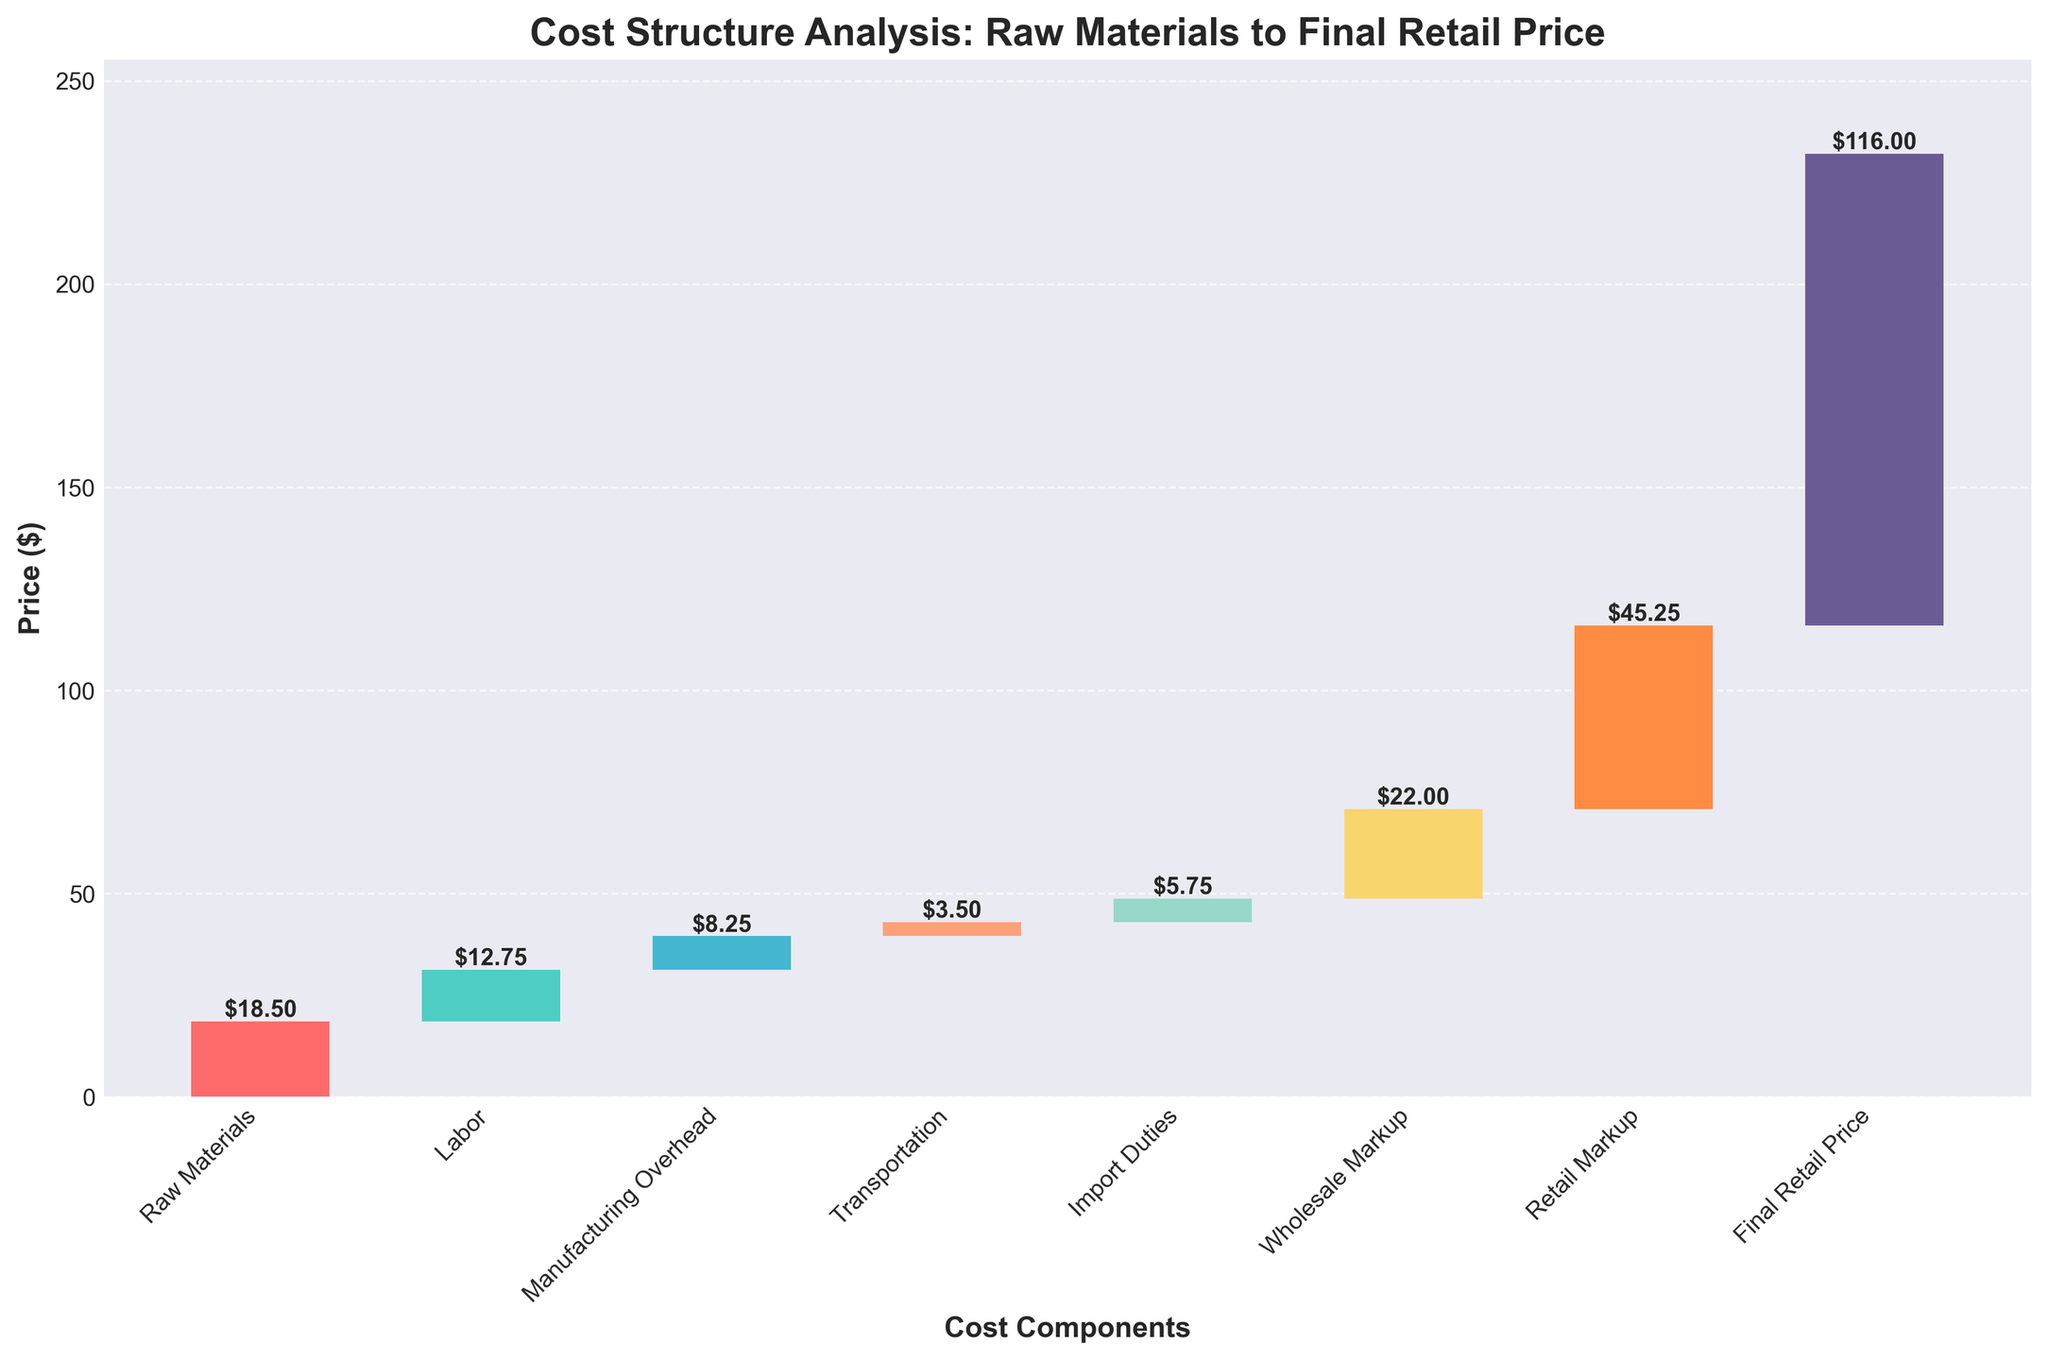What is the title of the chart? The title is positioned at the top of the chart and is indicated in a larger, bold font.
Answer: Cost Structure Analysis: Raw Materials to Final Retail Price How many cost components are included in the analysis? By counting the bars on the x-axis, each representing a different cost component, we see there are eight categories.
Answer: 8 Which cost component has the highest value? By comparing the lengths of the bars, the longest bar corresponds to the 'Final Retail Price'.
Answer: Final Retail Price What is the value of 'Labor'? The value is placed directly above the bar labeled 'Labor'.
Answer: 12.75 What is the cumulative cost up to 'Transportation'? By summing the values of Raw Materials, Labor, Manufacturing Overhead, and Transportation: 18.50 + 12.75 + 8.25 + 3.50 = 43.00
Answer: 43.00 How much higher is the 'Retail Markup' compared to the 'Wholesale Markup'? Subtract the value of Wholesale Markup from Retail Markup: 45.25 - 22.00 = 23.25
Answer: 23.25 What is the average cost of 'Raw Materials', 'Labor', and 'Manufacturing Overhead'? Calculate the sum of the three values and divide by 3: (18.50 + 12.75 + 8.25) / 3 = 13.17
Answer: 13.17 Compare the values of 'Import Duties' and 'Transportation'. Which one is higher and by how much? Subtract the value of Transportation from Import Duties: 5.75 - 3.50 = 2.25
Answer: Import Duties are higher by 2.25 What is the total of all the intermediate costs excluding the 'Final Retail Price'? Sum all costs excluding the 'Final Retail Price': 18.50 + 12.75 + 8.25 + 3.50 + 5.75 + 22.00 + 45.25 = 116.00
Answer: 116.00 What is the difference between the cumulative cost up to 'Wholesale Markup' and the 'Final Retail Price'? Subtract the cumulative cost up to Wholesale Markup (70.75) from the Final Retail Price: 116.00 - 70.75 = 45.25
Answer: 45.25 